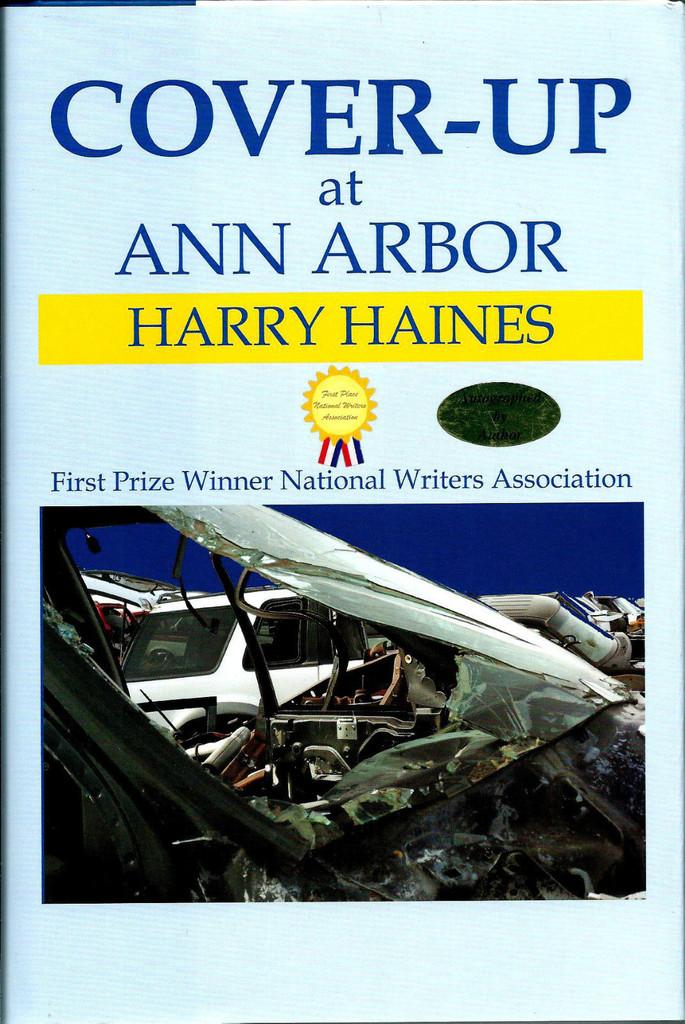What's the name of the book written about ann harbor by harry haines?
Ensure brevity in your answer.  Cover-up. Who is the author of this book?
Your answer should be very brief. Harry haines. 